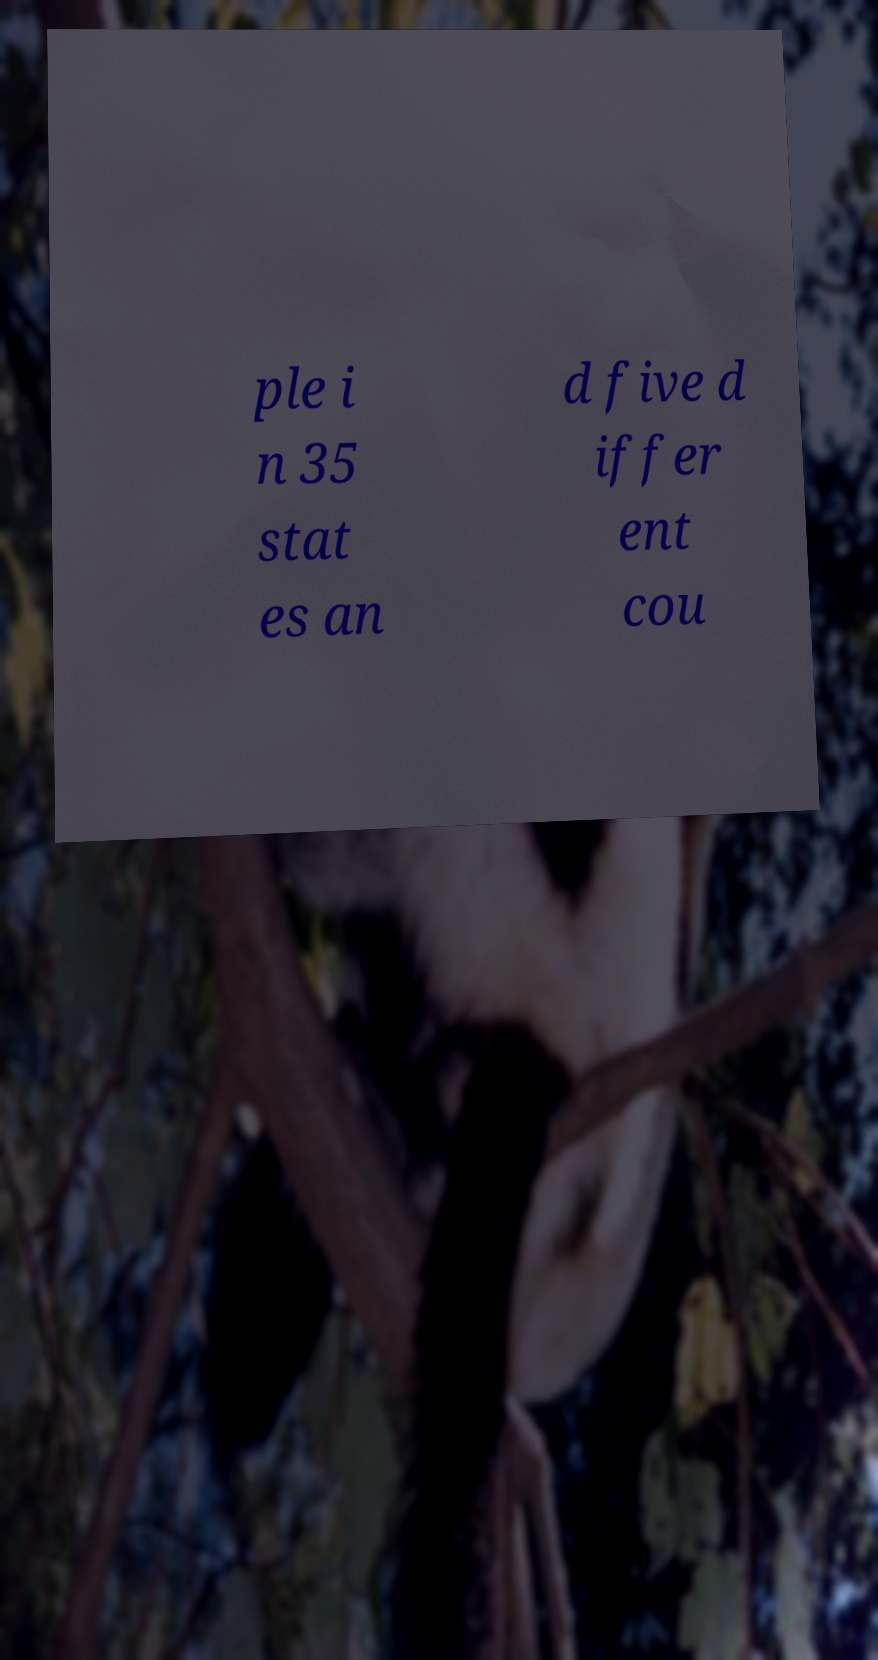Please read and relay the text visible in this image. What does it say? ple i n 35 stat es an d five d iffer ent cou 